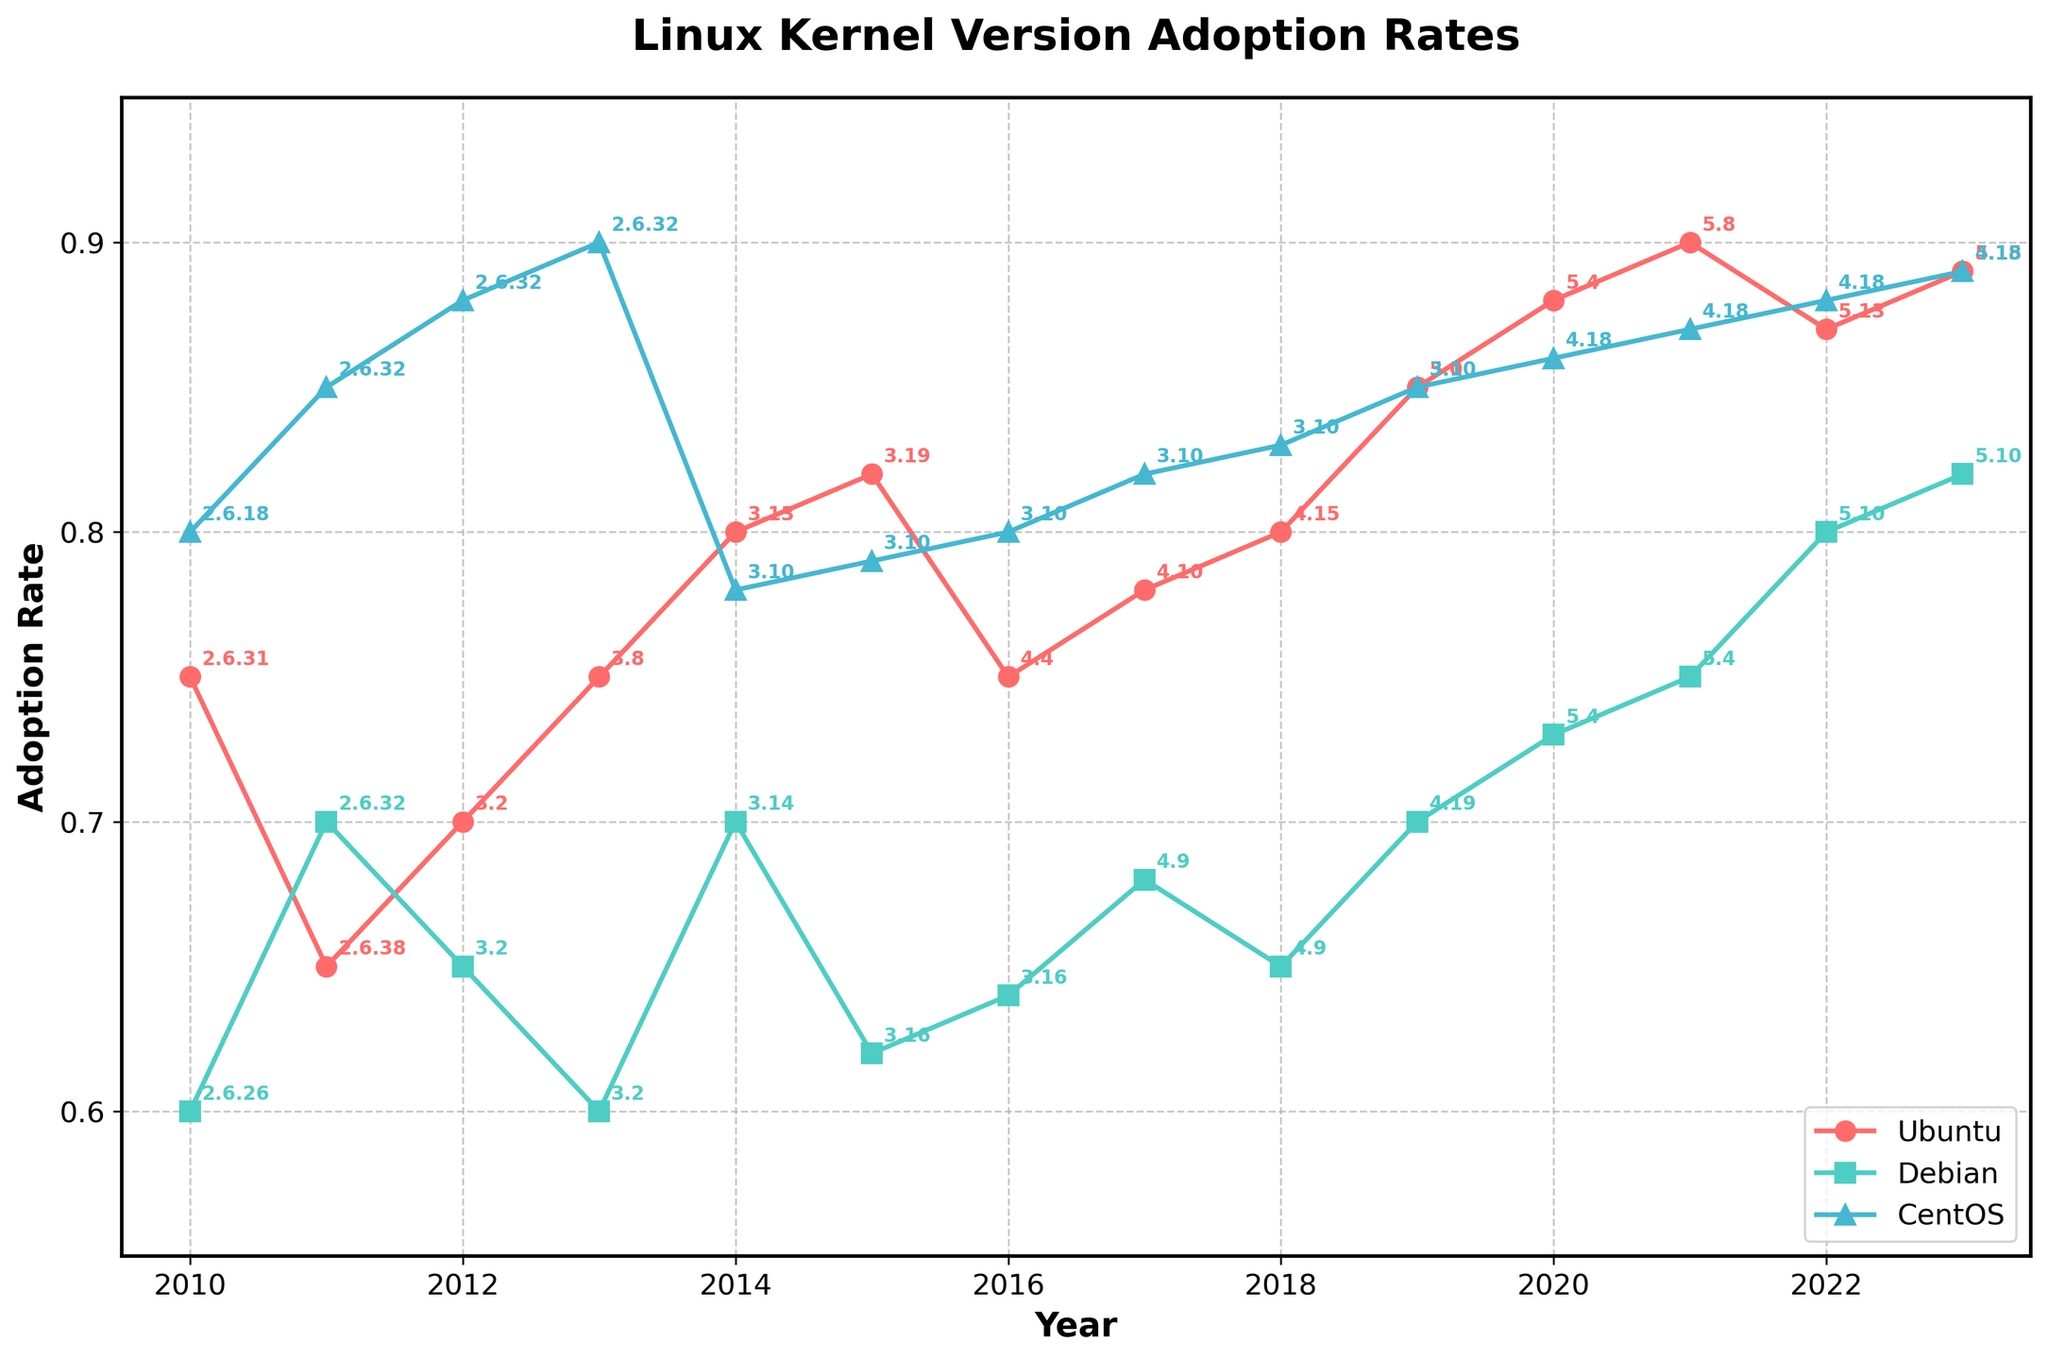What is the title of the figure? The title of the figure is located at the top center and is usually larger and bold. By reading this area, you can identify the title as "Linux Kernel Version Adoption Rates".
Answer: Linux Kernel Version Adoption Rates What is the adoption rate for CentOS in 2013? Find the CentOS data line and refer to the year 2013. The adoption rate is marked at the intersection point. The plot shows a rate near 0.90.
Answer: 0.90 Which distribution had the highest adoption rate in 2020? Check the year 2020 on the x-axis and compare the rates of each distribution (Ubuntu, Debian, CentOS). The highest point belongs to Ubuntu at 0.88.
Answer: Ubuntu How does the adoption rate of Debian in 2015 compare to that in 2016? Locate the Debian data points for 2015 (0.62) and 2016 (0.64) on the y-axis. Since 0.62 < 0.64, the rate increased from 2015 to 2016.
Answer: Increased What is the average adoption rate of Ubuntu from 2010 to 2012? Locate the Ubuntu data points for 2010 (0.75), 2011 (0.65), and 2012 (0.70). Sum these values: 0.75 + 0.65 + 0.70 = 2.10. Divide by the number of years (3): 2.10 / 3 = 0.70.
Answer: 0.70 Which distribution had the most consistent adoption rate from 2019 to 2023? Compare the plots of each distribution between 2019 and 2023. CentOS shows a relatively stable trend with adoption rates very close to each other every year.
Answer: CentOS In which year did all distributions show the highest adoption rate? Compare the highest points for all distributions and the years they occurred. In 2023, all distributions (Ubuntu, Debian, CentOS) reached their peak adoption rates.
Answer: 2023 